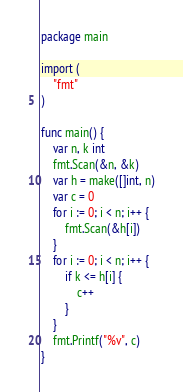Convert code to text. <code><loc_0><loc_0><loc_500><loc_500><_Go_>package main

import (
	"fmt"
)

func main() {
	var n, k int
	fmt.Scan(&n, &k)
	var h = make([]int, n)
	var c = 0
	for i := 0; i < n; i++ {
		fmt.Scan(&h[i])
	}
	for i := 0; i < n; i++ {
		if k <= h[i] {
			c++
		}
	}
	fmt.Printf("%v", c)
}</code> 